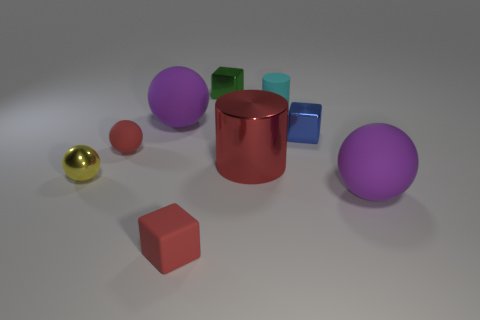Is the tiny metal ball the same color as the small matte ball?
Offer a terse response. No. What number of red objects are either cylinders or matte cubes?
Make the answer very short. 2. The small cylinder has what color?
Your answer should be very brief. Cyan. The green block that is made of the same material as the small yellow object is what size?
Keep it short and to the point. Small. What number of small red matte objects have the same shape as the blue thing?
Keep it short and to the point. 1. Is there anything else that has the same size as the red cylinder?
Offer a very short reply. Yes. How big is the blue cube on the right side of the large purple matte object to the left of the blue block?
Your response must be concise. Small. There is a cyan cylinder that is the same size as the blue object; what material is it?
Offer a terse response. Rubber. Are there any balls made of the same material as the tiny yellow thing?
Provide a short and direct response. No. What color is the large rubber thing that is right of the green metal object right of the big purple matte object behind the tiny yellow sphere?
Provide a succinct answer. Purple. 